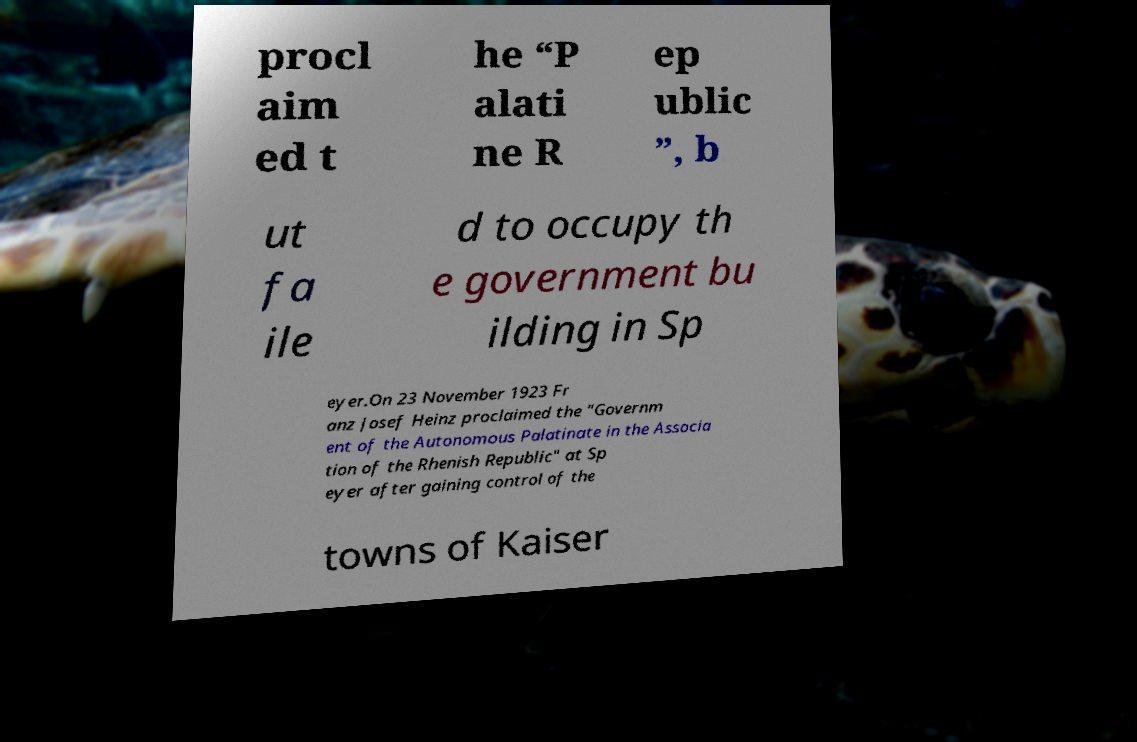Please read and relay the text visible in this image. What does it say? procl aim ed t he “P alati ne R ep ublic ”, b ut fa ile d to occupy th e government bu ilding in Sp eyer.On 23 November 1923 Fr anz Josef Heinz proclaimed the "Governm ent of the Autonomous Palatinate in the Associa tion of the Rhenish Republic" at Sp eyer after gaining control of the towns of Kaiser 